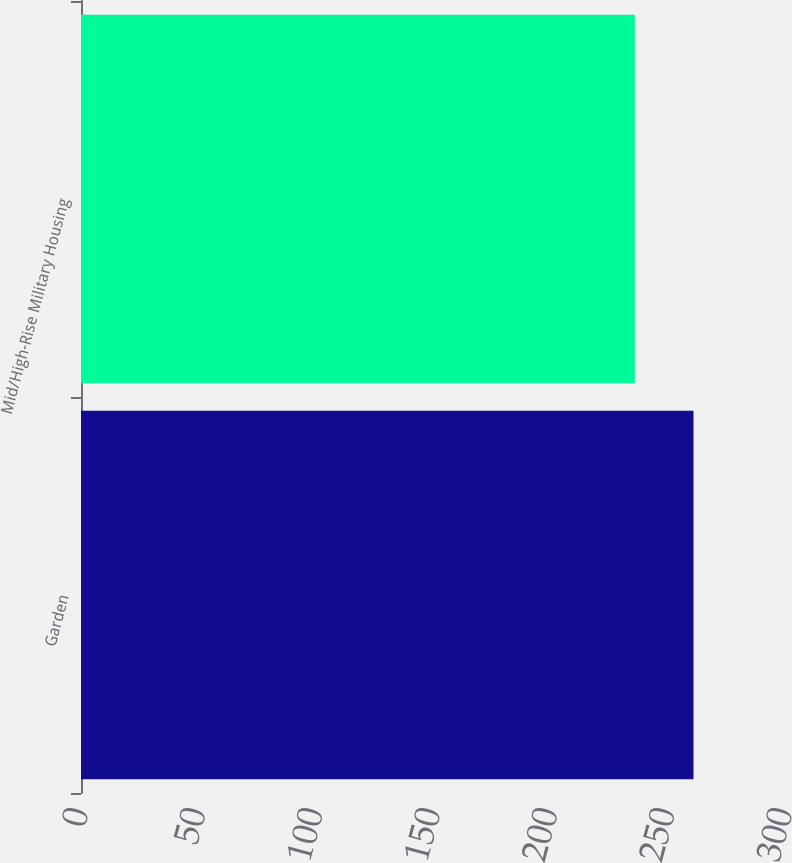<chart> <loc_0><loc_0><loc_500><loc_500><bar_chart><fcel>Garden<fcel>Mid/High-Rise Military Housing<nl><fcel>261<fcel>236<nl></chart> 